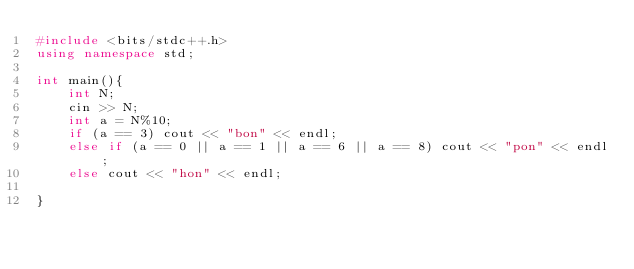Convert code to text. <code><loc_0><loc_0><loc_500><loc_500><_C++_>#include <bits/stdc++.h>
using namespace std;

int main(){
	int N;
	cin >> N;
	int a = N%10;
	if (a == 3) cout << "bon" << endl;
	else if (a == 0 || a == 1 || a == 6 || a == 8) cout << "pon" << endl;
	else cout << "hon" << endl;

}

</code> 